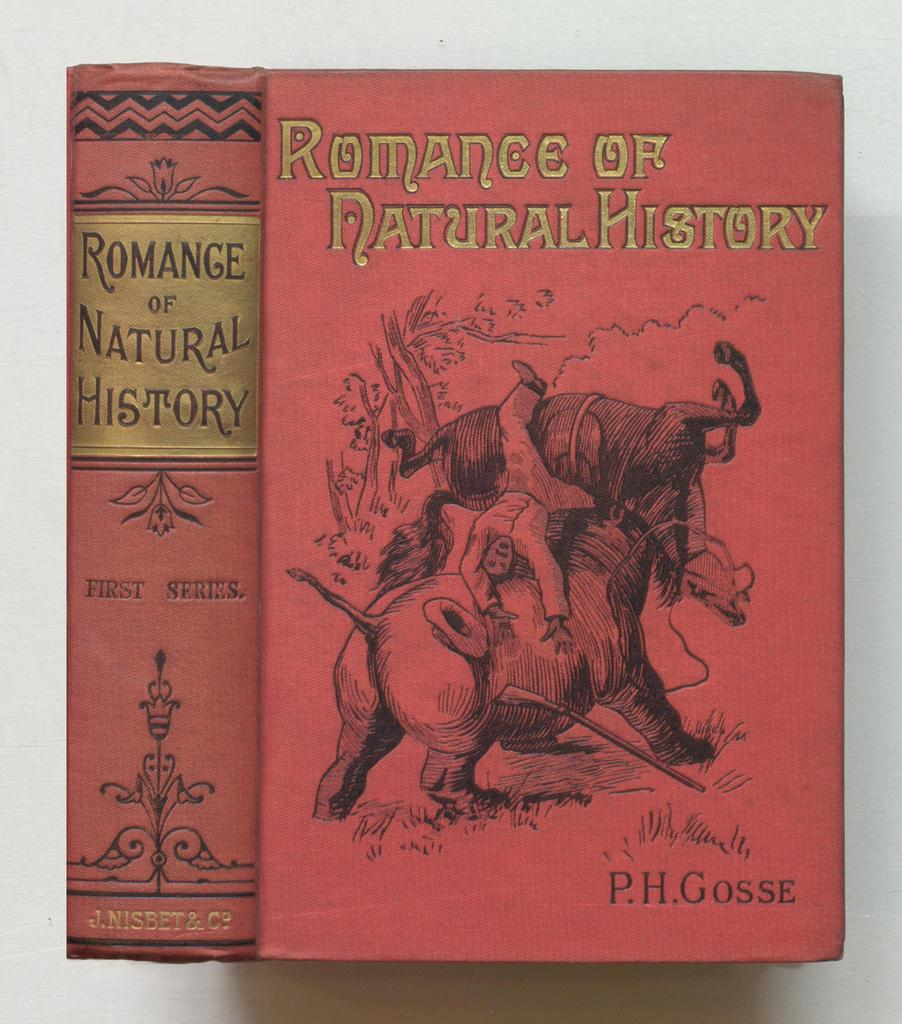Provide a one-sentence caption for the provided image. a book titled romance of natural history is shown. 